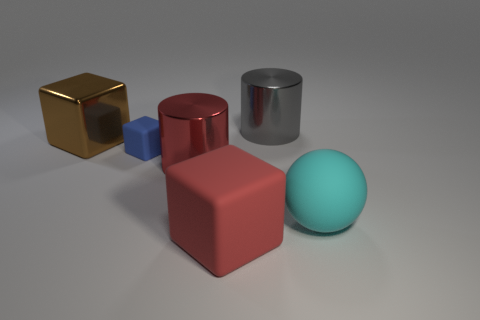Subtract all large cubes. How many cubes are left? 1 Subtract all gray cylinders. How many cylinders are left? 1 Subtract 3 blocks. How many blocks are left? 0 Subtract all cylinders. How many objects are left? 4 Subtract all yellow cubes. Subtract all blue cylinders. How many cubes are left? 3 Subtract all yellow cylinders. How many brown cubes are left? 1 Add 3 large brown metal balls. How many large brown metal balls exist? 3 Add 3 red metallic spheres. How many objects exist? 9 Subtract 0 green cylinders. How many objects are left? 6 Subtract all big balls. Subtract all big cyan balls. How many objects are left? 4 